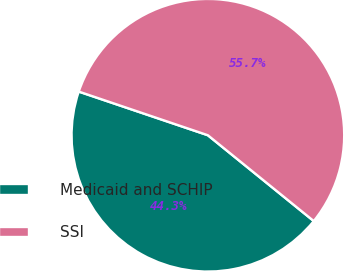Convert chart. <chart><loc_0><loc_0><loc_500><loc_500><pie_chart><fcel>Medicaid and SCHIP<fcel>SSI<nl><fcel>44.35%<fcel>55.65%<nl></chart> 